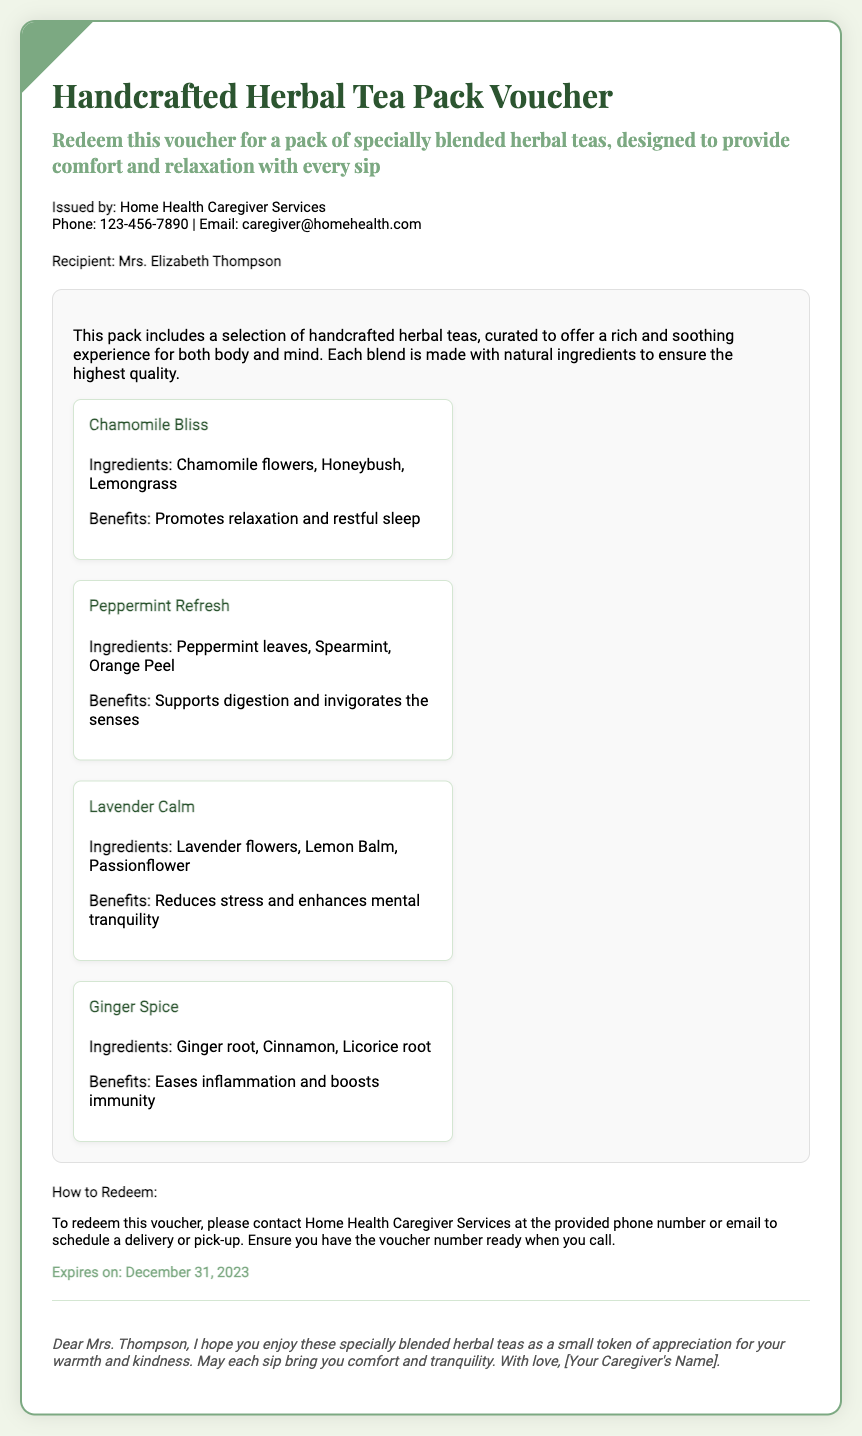What is the name of the herbal tea pack? The name of the herbal tea pack is mentioned at the top of the voucher.
Answer: Handcrafted Herbal Tea Pack Voucher Who is the recipient of the voucher? The recipient's name is listed under the recipient section of the document.
Answer: Mrs. Elizabeth Thompson How many different herbal teas are included in the pack? The number of teas can be counted in the tea list section of the voucher.
Answer: Four What is one benefit of Chamomile Bliss? The benefits of each tea are stated in the description under the tea item.
Answer: Promotes relaxation and restful sleep How can this voucher be redeemed? The redemption instructions are provided in the section detailing how to redeem the voucher.
Answer: Contact Home Health Caregiver Services What is the expiration date of the voucher? The expiration date is clearly specified in the redemption section of the document.
Answer: December 31, 2023 Who issued the voucher? The issuer's details are mentioned right after the title of the voucher.
Answer: Home Health Caregiver Services What ingredients are in Ginger Spice? The ingredients for each tea are listed under the respective tea items in the document.
Answer: Ginger root, Cinnamon, Licorice root What type of document is this? The title and purpose of the document indicate its category.
Answer: Gift voucher 